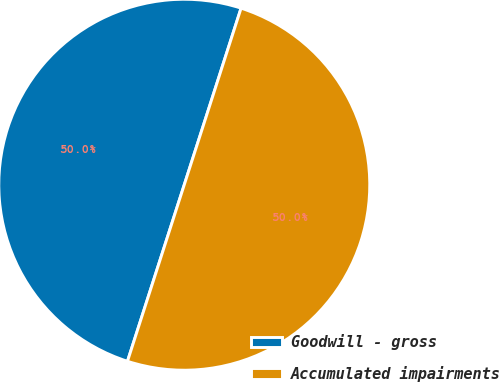Convert chart to OTSL. <chart><loc_0><loc_0><loc_500><loc_500><pie_chart><fcel>Goodwill - gross<fcel>Accumulated impairments<nl><fcel>50.0%<fcel>50.0%<nl></chart> 